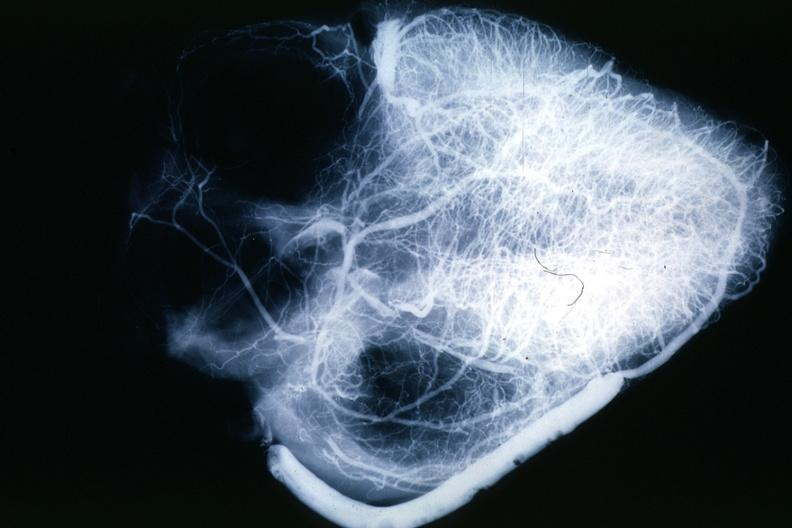what is present?
Answer the question using a single word or phrase. Cardiovascular 